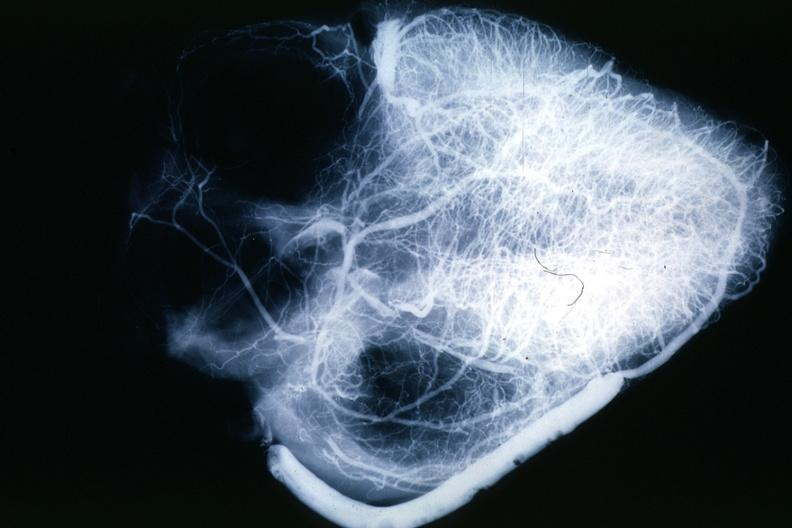what is present?
Answer the question using a single word or phrase. Cardiovascular 